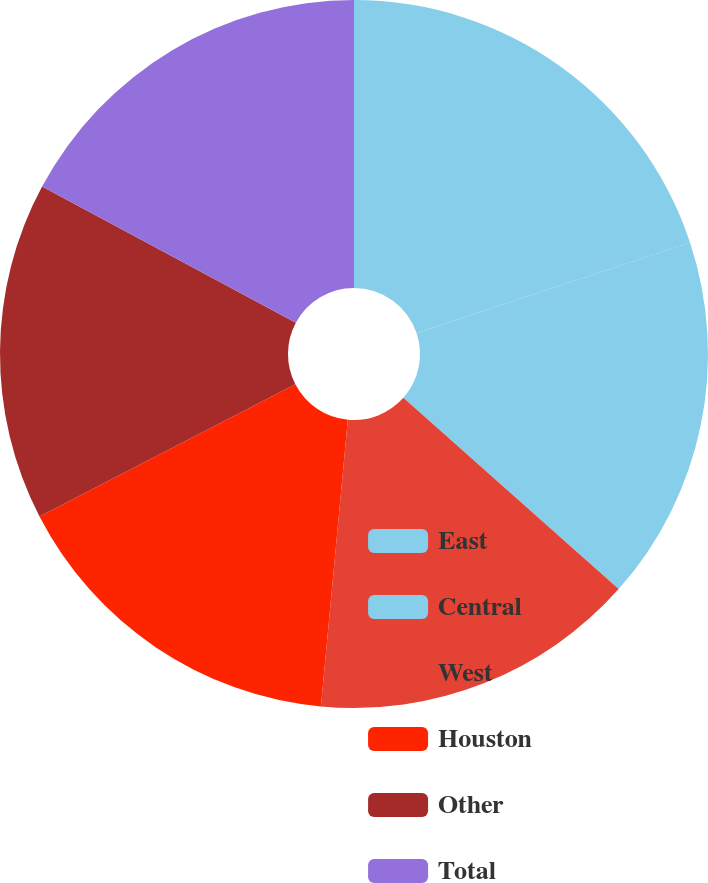Convert chart. <chart><loc_0><loc_0><loc_500><loc_500><pie_chart><fcel>East<fcel>Central<fcel>West<fcel>Houston<fcel>Other<fcel>Total<nl><fcel>19.9%<fcel>16.66%<fcel>14.93%<fcel>15.92%<fcel>15.43%<fcel>17.16%<nl></chart> 